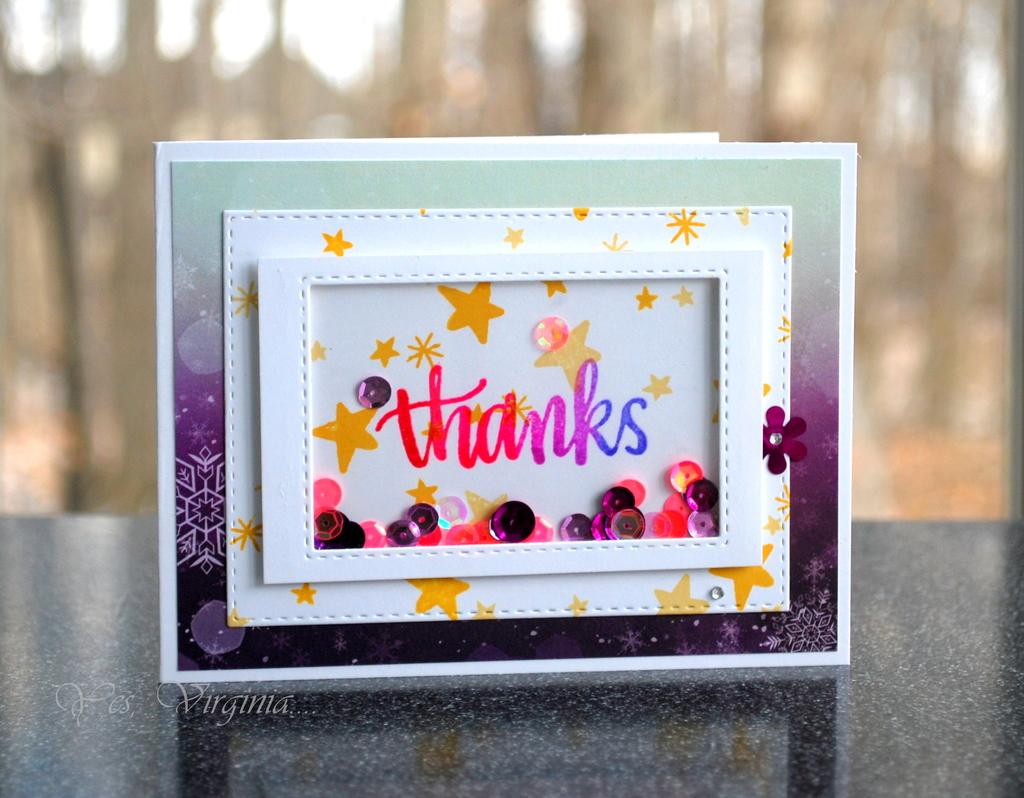<image>
Render a clear and concise summary of the photo. A very colorful and decorative card that reads thanks on the front. 